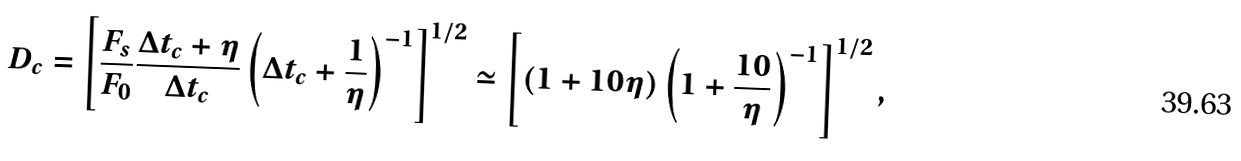<formula> <loc_0><loc_0><loc_500><loc_500>D _ { c } = \left [ \frac { F _ { s } } { F _ { 0 } } \frac { \Delta t _ { c } + \eta } { \Delta t _ { c } } \left ( \Delta t _ { c } + \frac { 1 } { \eta } \right ) ^ { - 1 } \right ] ^ { 1 / 2 } \simeq \left [ ( 1 + 1 0 \eta ) \left ( 1 + \frac { 1 0 } { \eta } \right ) ^ { - 1 } \right ] ^ { 1 / 2 } ,</formula> 